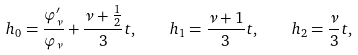<formula> <loc_0><loc_0><loc_500><loc_500>h _ { 0 } = \frac { \varphi _ { \nu } ^ { \prime } } { \varphi _ { \nu } } + \frac { \nu + \frac { 1 } { 2 } } { 3 } t , \quad h _ { 1 } = \frac { \nu + 1 } { 3 } t , \quad h _ { 2 } = \frac { \nu } { 3 } t ,</formula> 